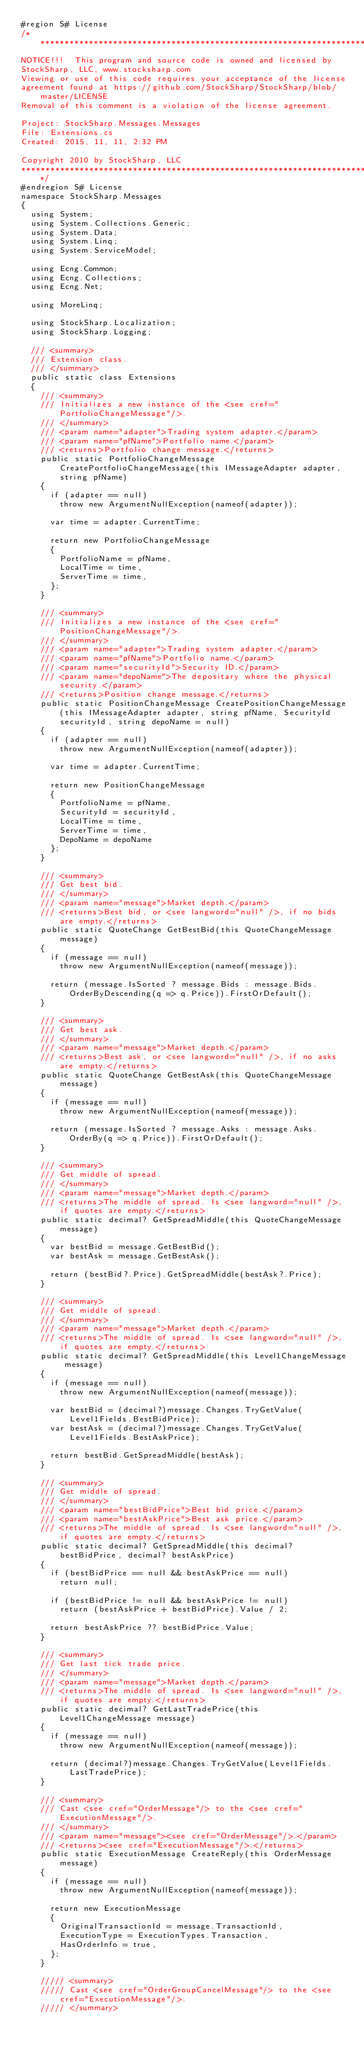Convert code to text. <code><loc_0><loc_0><loc_500><loc_500><_C#_>#region S# License
/******************************************************************************************
NOTICE!!!  This program and source code is owned and licensed by
StockSharp, LLC, www.stocksharp.com
Viewing or use of this code requires your acceptance of the license
agreement found at https://github.com/StockSharp/StockSharp/blob/master/LICENSE
Removal of this comment is a violation of the license agreement.

Project: StockSharp.Messages.Messages
File: Extensions.cs
Created: 2015, 11, 11, 2:32 PM

Copyright 2010 by StockSharp, LLC
*******************************************************************************************/
#endregion S# License
namespace StockSharp.Messages
{
	using System;
	using System.Collections.Generic;
	using System.Data;
	using System.Linq;
	using System.ServiceModel;

	using Ecng.Common;
	using Ecng.Collections;
	using Ecng.Net;

	using MoreLinq;

	using StockSharp.Localization;
	using StockSharp.Logging;

	/// <summary>
	/// Extension class.
	/// </summary>
	public static class Extensions
	{
		/// <summary>
		/// Initializes a new instance of the <see cref="PortfolioChangeMessage"/>.
		/// </summary>
		/// <param name="adapter">Trading system adapter.</param>
		/// <param name="pfName">Portfolio name.</param>
		/// <returns>Portfolio change message.</returns>
		public static PortfolioChangeMessage CreatePortfolioChangeMessage(this IMessageAdapter adapter, string pfName)
		{
			if (adapter == null)
				throw new ArgumentNullException(nameof(adapter));

			var time = adapter.CurrentTime;

			return new PortfolioChangeMessage
			{
				PortfolioName = pfName,
				LocalTime = time,
				ServerTime = time,
			};
		}

		/// <summary>
		/// Initializes a new instance of the <see cref="PositionChangeMessage"/>.
		/// </summary>
		/// <param name="adapter">Trading system adapter.</param>
		/// <param name="pfName">Portfolio name.</param>
		/// <param name="securityId">Security ID.</param>
		/// <param name="depoName">The depositary where the physical security.</param>
		/// <returns>Position change message.</returns>
		public static PositionChangeMessage CreatePositionChangeMessage(this IMessageAdapter adapter, string pfName, SecurityId securityId, string depoName = null)
		{
			if (adapter == null)
				throw new ArgumentNullException(nameof(adapter));

			var time = adapter.CurrentTime;

			return new PositionChangeMessage
			{
				PortfolioName = pfName,
				SecurityId = securityId,
				LocalTime = time,
				ServerTime = time,
				DepoName = depoName
			};
		}

		/// <summary>
		/// Get best bid.
		/// </summary>
		/// <param name="message">Market depth.</param>
		/// <returns>Best bid, or <see langword="null" />, if no bids are empty.</returns>
		public static QuoteChange GetBestBid(this QuoteChangeMessage message)
		{
			if (message == null)
				throw new ArgumentNullException(nameof(message));

			return (message.IsSorted ? message.Bids : message.Bids.OrderByDescending(q => q.Price)).FirstOrDefault();
		}

		/// <summary>
		/// Get best ask.
		/// </summary>
		/// <param name="message">Market depth.</param>
		/// <returns>Best ask, or <see langword="null" />, if no asks are empty.</returns>
		public static QuoteChange GetBestAsk(this QuoteChangeMessage message)
		{
			if (message == null)
				throw new ArgumentNullException(nameof(message));

			return (message.IsSorted ? message.Asks : message.Asks.OrderBy(q => q.Price)).FirstOrDefault();
		}

		/// <summary>
		/// Get middle of spread.
		/// </summary>
		/// <param name="message">Market depth.</param>
		/// <returns>The middle of spread. Is <see langword="null" />, if quotes are empty.</returns>
		public static decimal? GetSpreadMiddle(this QuoteChangeMessage message)
		{
			var bestBid = message.GetBestBid();
			var bestAsk = message.GetBestAsk();

			return (bestBid?.Price).GetSpreadMiddle(bestAsk?.Price);
		}

		/// <summary>
		/// Get middle of spread.
		/// </summary>
		/// <param name="message">Market depth.</param>
		/// <returns>The middle of spread. Is <see langword="null" />, if quotes are empty.</returns>
		public static decimal? GetSpreadMiddle(this Level1ChangeMessage message)
		{
			if (message == null)
				throw new ArgumentNullException(nameof(message));

			var bestBid = (decimal?)message.Changes.TryGetValue(Level1Fields.BestBidPrice);
			var bestAsk = (decimal?)message.Changes.TryGetValue(Level1Fields.BestAskPrice);

			return bestBid.GetSpreadMiddle(bestAsk);
		}

		/// <summary>
		/// Get middle of spread.
		/// </summary>
		/// <param name="bestBidPrice">Best bid price.</param>
		/// <param name="bestAskPrice">Best ask price.</param>
		/// <returns>The middle of spread. Is <see langword="null" />, if quotes are empty.</returns>
		public static decimal? GetSpreadMiddle(this decimal? bestBidPrice, decimal? bestAskPrice)
		{
			if (bestBidPrice == null && bestAskPrice == null)
				return null;

			if (bestBidPrice != null && bestAskPrice != null)
				return (bestAskPrice + bestBidPrice).Value / 2;

			return bestAskPrice ?? bestBidPrice.Value;
		}

		/// <summary>
		/// Get last tick trade price.
		/// </summary>
		/// <param name="message">Market depth.</param>
		/// <returns>The middle of spread. Is <see langword="null" />, if quotes are empty.</returns>
		public static decimal? GetLastTradePrice(this Level1ChangeMessage message)
		{
			if (message == null)
				throw new ArgumentNullException(nameof(message));

			return (decimal?)message.Changes.TryGetValue(Level1Fields.LastTradePrice);
		}

		/// <summary>
		/// Cast <see cref="OrderMessage"/> to the <see cref="ExecutionMessage"/>.
		/// </summary>
		/// <param name="message"><see cref="OrderMessage"/>.</param>
		/// <returns><see cref="ExecutionMessage"/>.</returns>
		public static ExecutionMessage CreateReply(this OrderMessage message)
		{
			if (message == null)
				throw new ArgumentNullException(nameof(message));

			return new ExecutionMessage
			{
				OriginalTransactionId = message.TransactionId,
				ExecutionType = ExecutionTypes.Transaction,
				HasOrderInfo = true,
			};
		}

		///// <summary>
		///// Cast <see cref="OrderGroupCancelMessage"/> to the <see cref="ExecutionMessage"/>.
		///// </summary></code> 